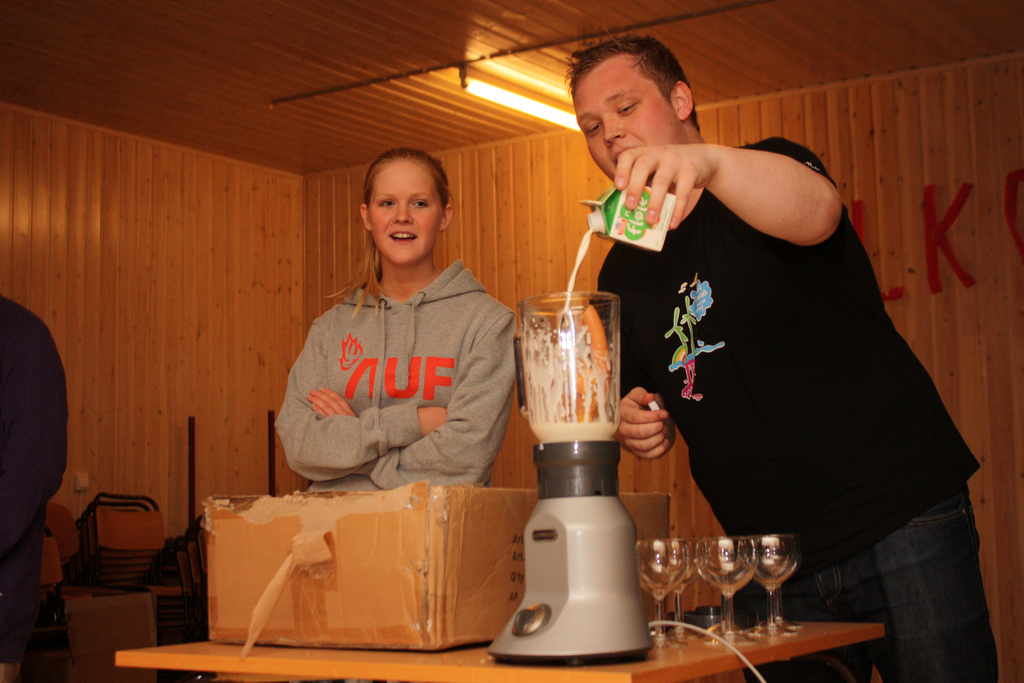Provide a one-sentence caption for the provided image.
Reference OCR token: K, MUF Two people in a wood paneled room with the girl on the left wearing a grey sweatshirt labeled "UF". 